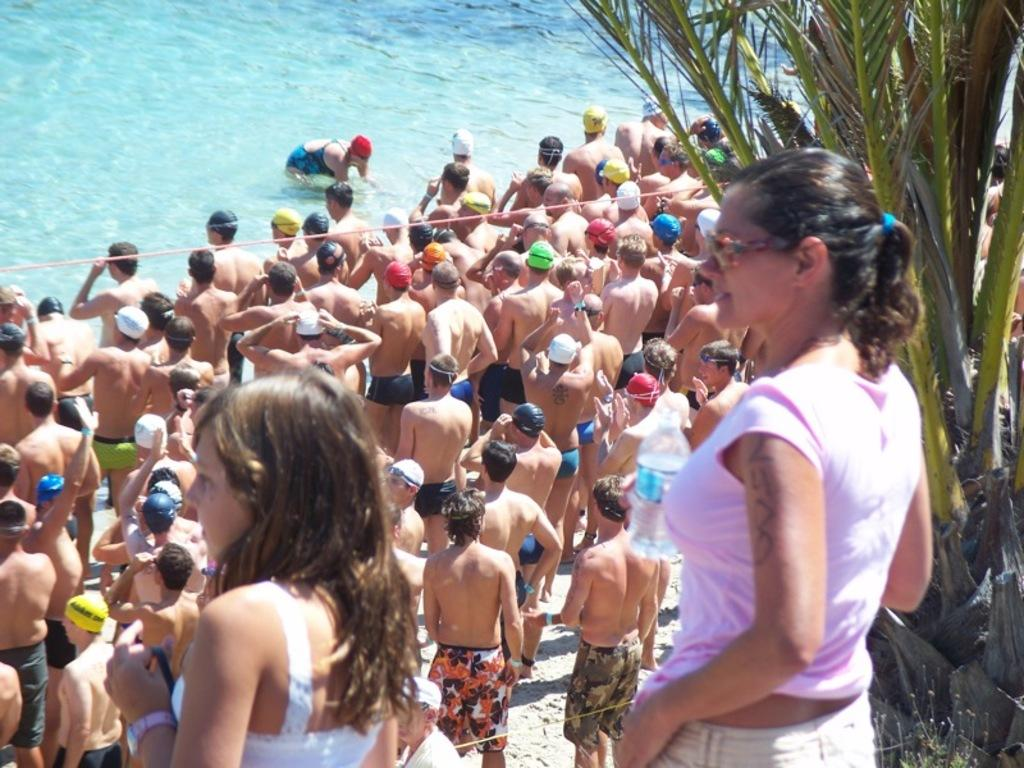What can be found on the left side of the image? There is a swimming pool on the left side of the image. What type of surface is present in the image? There is sand in the image. What are the people near the swimming pool wearing? The people standing near the swimming pool are wearing swim dresses. What can be seen on the right side of the image? There is a tree on the right side of the image. What type of instrument is being played by the grandmother in the image? There is no grandmother or instrument present in the image. What need do the people standing near the swimming pool have in the image? The provided facts do not indicate any specific needs of the people in the image. 